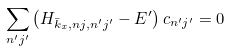Convert formula to latex. <formula><loc_0><loc_0><loc_500><loc_500>\sum _ { n ^ { \prime } j ^ { \prime } } \left ( H _ { \bar { k } _ { x } , n j , n ^ { \prime } j ^ { \prime } } - E ^ { \prime } \right ) c _ { n ^ { \prime } j ^ { \prime } } = 0</formula> 